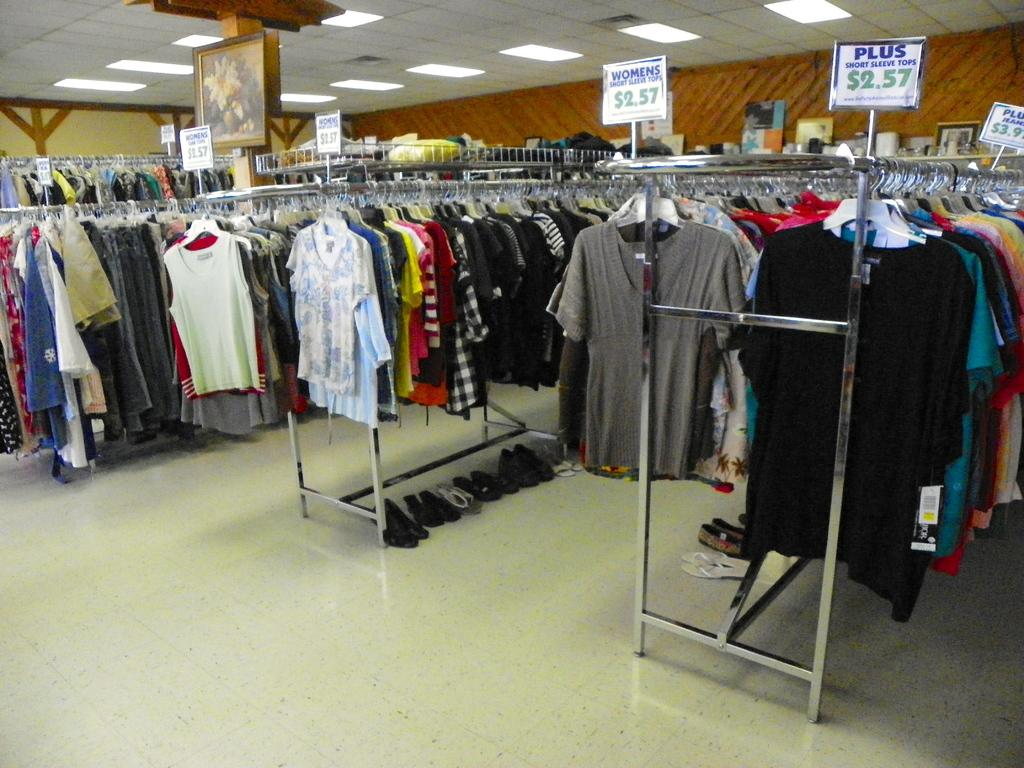Provide a one-sentence caption for the provided image. A rack of clothing, one of which is advertising clothes for 2.57. 